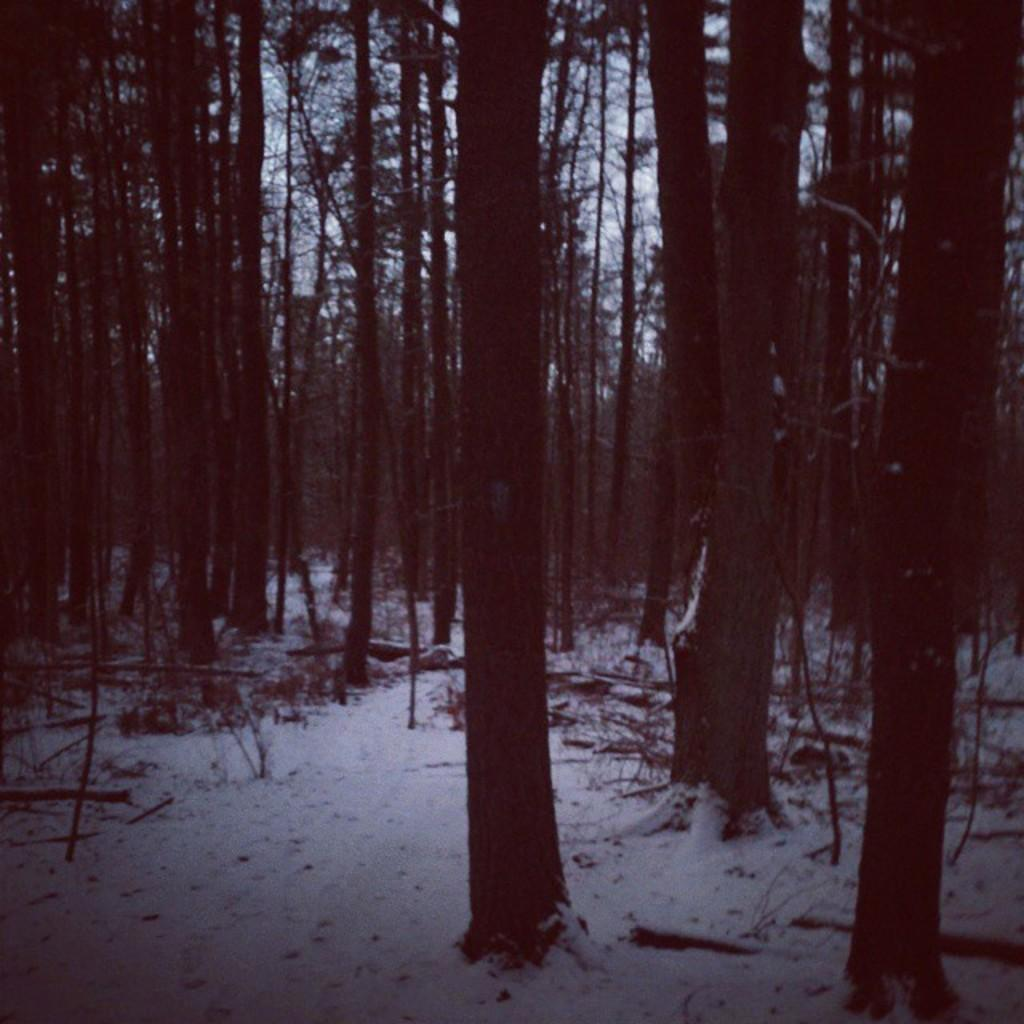What is the condition of the ground in the image? The ground is covered with snow. What type of vegetation can be seen in the image? There are plants and trees in the image. How are the plants and trees affected by the snow? The plants and trees are covered with snow. What is the weather like in the image? The sky is cloudy in the image. Can you see a woman's body in the image? There is no woman or her body present in the image. Are there any cacti visible in the image? There are no cacti present in the image; the vegetation consists of plants and trees covered with snow. 